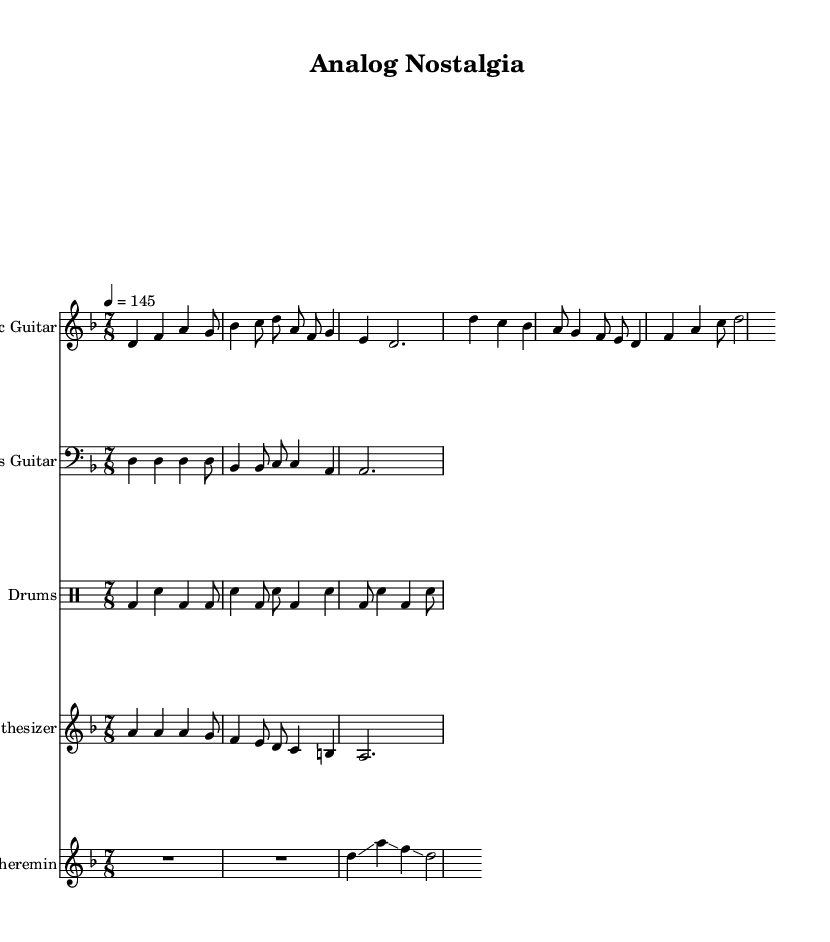What is the key signature of this music? The key signature is D minor, which has one flat (B flat). This is indicated at the beginning of the staff.
Answer: D minor What is the time signature of this piece? The time signature is 7/8, which means there are seven eighth-note beats in each measure. This is clearly marked at the beginning of the music.
Answer: 7/8 What is the tempo indicated in this score? The tempo marking is 4 = 145, meaning the quarter note is to be played at 145 beats per minute. This information is provided at the beginning of the score.
Answer: 145 Which instrument plays a glissando in this composition? The theremin is the instrument that plays glissando, as indicated in the respective measures.
Answer: Theremin How many measures are there in the electric guitar part? The electric guitar part contains four measures, as can be counted from the notation in the staff.
Answer: 4 What rhythmic pattern do the drums follow in the first two measures? The drums feature a pattern primarily of bass drum and snare hits, alternating throughout the first two measures. This rhythmic structure is typical in metal music, emphasizing the downbeat.
Answer: Bass and snare What style of production does this music experiment with? The music experiments with vintage recording techniques and retro production styles, as indicated by the overall sound design and instrumentation choices.
Answer: Vintage 